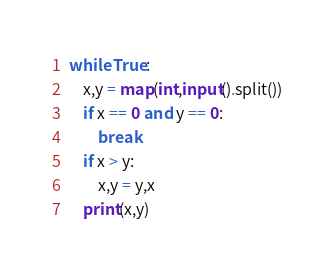<code> <loc_0><loc_0><loc_500><loc_500><_Python_>while True:
    x,y = map(int,input().split())
    if x == 0 and y == 0:
        break
    if x > y:
        x,y = y,x
    print(x,y)
</code> 